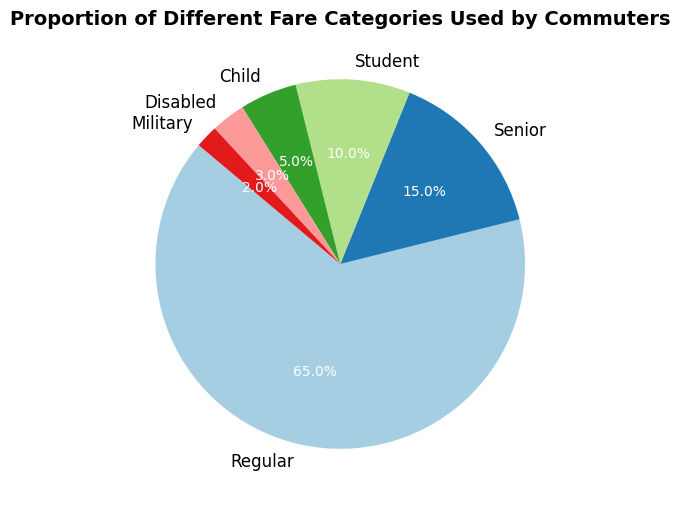What's the largest fare category in terms of proportion? The largest fare category can be identified by looking for the segment with the highest percentage. From the pie chart, the 'Regular' fare category has the largest proportion at 65%.
Answer: Regular Which fare category has the smallest proportion? The smallest fare category can be identified by finding the segment with the lowest percentage. From the pie chart, the 'Military' fare category has the smallest proportion at 2%.
Answer: Military What is the combined proportion of 'Senior' and 'Student' fare categories? To find the combined proportion, add the percentages of 'Senior' and 'Student'. From the chart, 'Senior' is 15% and 'Student' is 10%, so 15% + 10% = 25%.
Answer: 25% Are there more commuters using 'Child' or 'Disabled' fare category? To compare the proportions, look at the segments for 'Child' and 'Disabled'. 'Child' has a proportion of 5% and 'Disabled' has a proportion of 3%. Since 5% > 3%, there are more commuters using the 'Child' fare category.
Answer: Child Add up the proportions of 'Disabled' and 'Military' fare categories. What do you get? To add the proportions, sum the percentages of 'Disabled' and 'Military'. From the chart, 'Disabled' is 3% and 'Military' is 2%, so 3% + 2% = 5%.
Answer: 5% Which fare category has a larger proportion, 'Senior' or 'Student'? To determine which category is larger, compare the percentages. 'Senior' has a proportion of 15% and 'Student' has a proportion of 10%. Since 15% > 10%, the 'Senior' fare category has a larger proportion.
Answer: Senior What is the proportion difference between 'Regular' and 'Child'? To find the proportion difference, subtract the 'Child' proportion from the 'Regular' proportion. 'Regular' is 65% and 'Child' is 5%, so 65% - 5% = 60%.
Answer: 60% Does the combined proportion of 'Child', 'Disabled', and 'Military' surpass the 'Student' category? First, sum the proportions of 'Child', 'Disabled', and 'Military': 5% + 3% + 2% = 10%. Then, compare the result with the 'Student' proportion which is 10%. Since 10% equals 10%, the combined proportion does not surpass but equals the 'Student' category.
Answer: No What is the difference between the highest and the lowest fare category proportions? The highest fare category is 'Regular' at 65%, and the lowest fare category is 'Military' at 2%. The difference is 65% - 2% = 63%.
Answer: 63% How does the sum of all non-regular fare categories compare to the 'Regular' category? First, sum all non-regular categories: 15% (Senior) + 10% (Student) + 5% (Child) + 3% (Disabled) + 2% (Military) = 35%. Compare this with 'Regular', which is 65%. Since 35% < 65%, the sum of non-regular categories is less than the 'Regular' category.
Answer: Less 